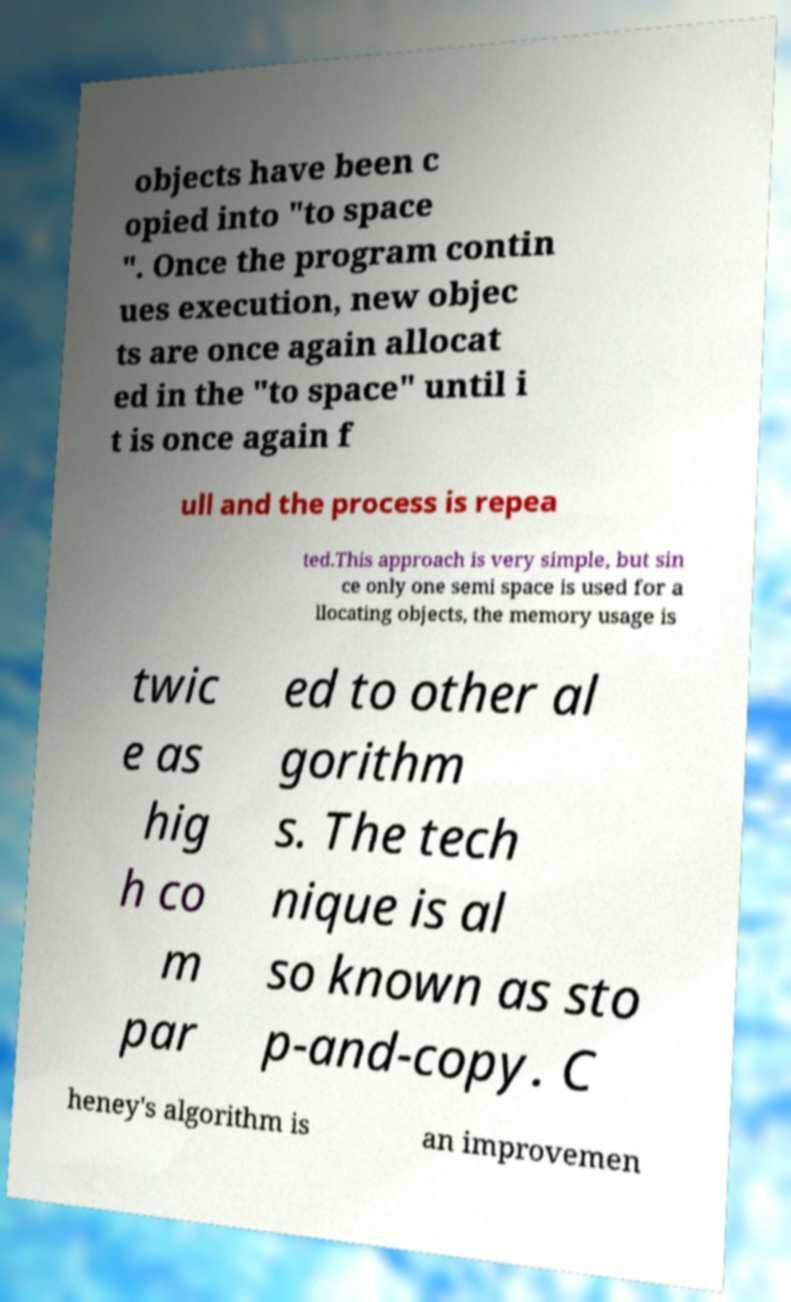Can you accurately transcribe the text from the provided image for me? objects have been c opied into "to space ". Once the program contin ues execution, new objec ts are once again allocat ed in the "to space" until i t is once again f ull and the process is repea ted.This approach is very simple, but sin ce only one semi space is used for a llocating objects, the memory usage is twic e as hig h co m par ed to other al gorithm s. The tech nique is al so known as sto p-and-copy. C heney's algorithm is an improvemen 